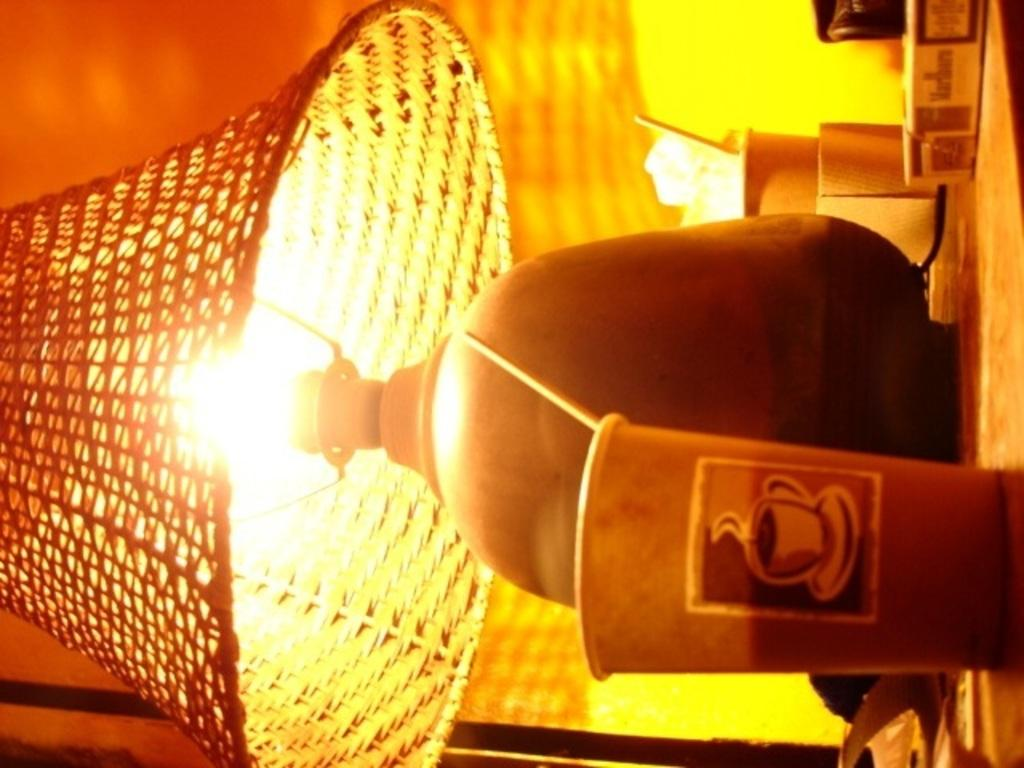What object can be seen providing light in the image? There is a lamp in the image. What items are on the table in the image? There are glasses on a table in the image. What type of stick can be seen holding up the lamp in the image? There is no stick holding up the lamp in the image; the lamp is likely standing on its base or attached to the ceiling. How many rings are visible on the glasses in the image? There is no mention of rings on the glasses in the image; the glasses are simply described as being on the table. 